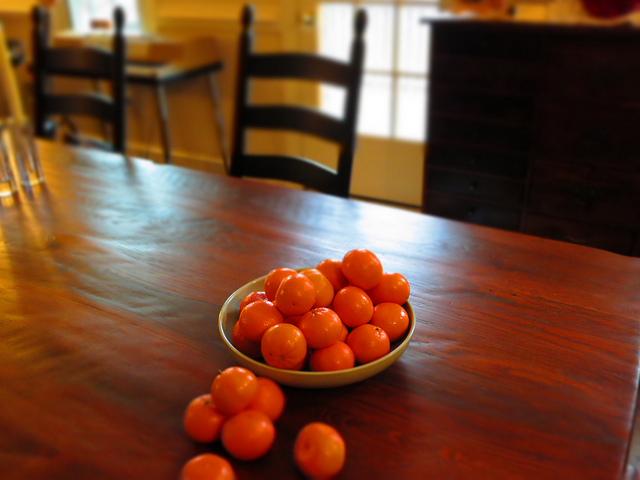What is making this room so bright?
Keep it brief. Sun. How many oranges are there?
Be succinct. 22. What color bowl are the oranges in?
Answer briefly. White. How many oranges that are not in the bowl?
Give a very brief answer. 6. Don't these oranges look delicious?
Short answer required. Yes. 